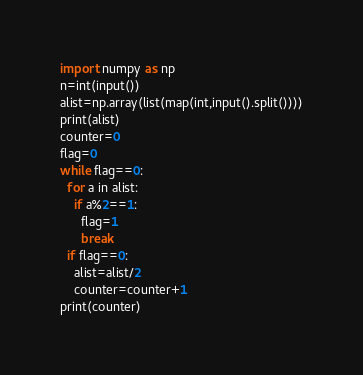Convert code to text. <code><loc_0><loc_0><loc_500><loc_500><_Python_>import numpy as np
n=int(input())
alist=np.array(list(map(int,input().split())))
print(alist)
counter=0
flag=0
while flag==0:
  for a in alist:
    if a%2==1:
      flag=1
      break
  if flag==0:
    alist=alist/2
    counter=counter+1
print(counter)</code> 